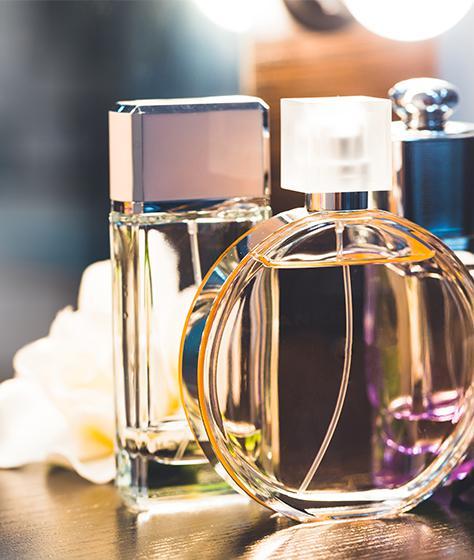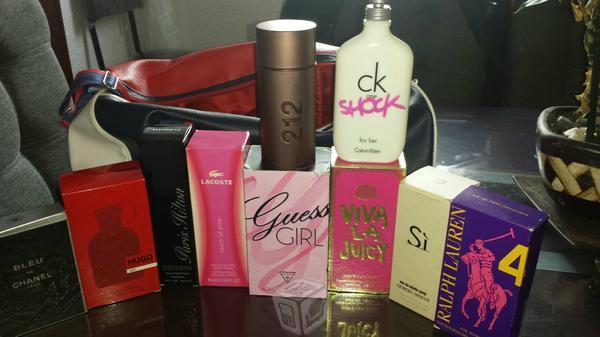The first image is the image on the left, the second image is the image on the right. Considering the images on both sides, is "In the image on the right, perfumes are stacked in front of a bag." valid? Answer yes or no. Yes. The first image is the image on the left, the second image is the image on the right. Considering the images on both sides, is "The left image includes at least one round glass fragrance bottle but does not include any boxes." valid? Answer yes or no. Yes. 